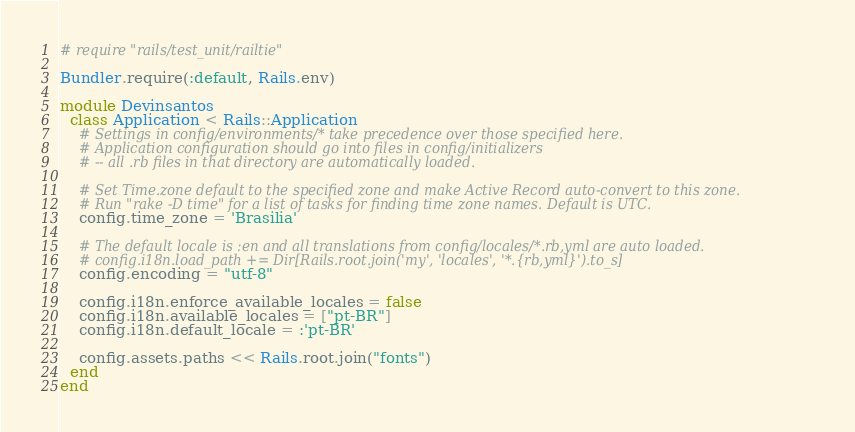Convert code to text. <code><loc_0><loc_0><loc_500><loc_500><_Ruby_># require "rails/test_unit/railtie"

Bundler.require(:default, Rails.env)

module Devinsantos
  class Application < Rails::Application
    # Settings in config/environments/* take precedence over those specified here.
    # Application configuration should go into files in config/initializers
    # -- all .rb files in that directory are automatically loaded.

    # Set Time.zone default to the specified zone and make Active Record auto-convert to this zone.
    # Run "rake -D time" for a list of tasks for finding time zone names. Default is UTC.
    config.time_zone = 'Brasilia'

    # The default locale is :en and all translations from config/locales/*.rb,yml are auto loaded.
    # config.i18n.load_path += Dir[Rails.root.join('my', 'locales', '*.{rb,yml}').to_s]
    config.encoding = "utf-8"

    config.i18n.enforce_available_locales = false
    config.i18n.available_locales = ["pt-BR"]
    config.i18n.default_locale = :'pt-BR'

    config.assets.paths << Rails.root.join("fonts")
  end
end
</code> 